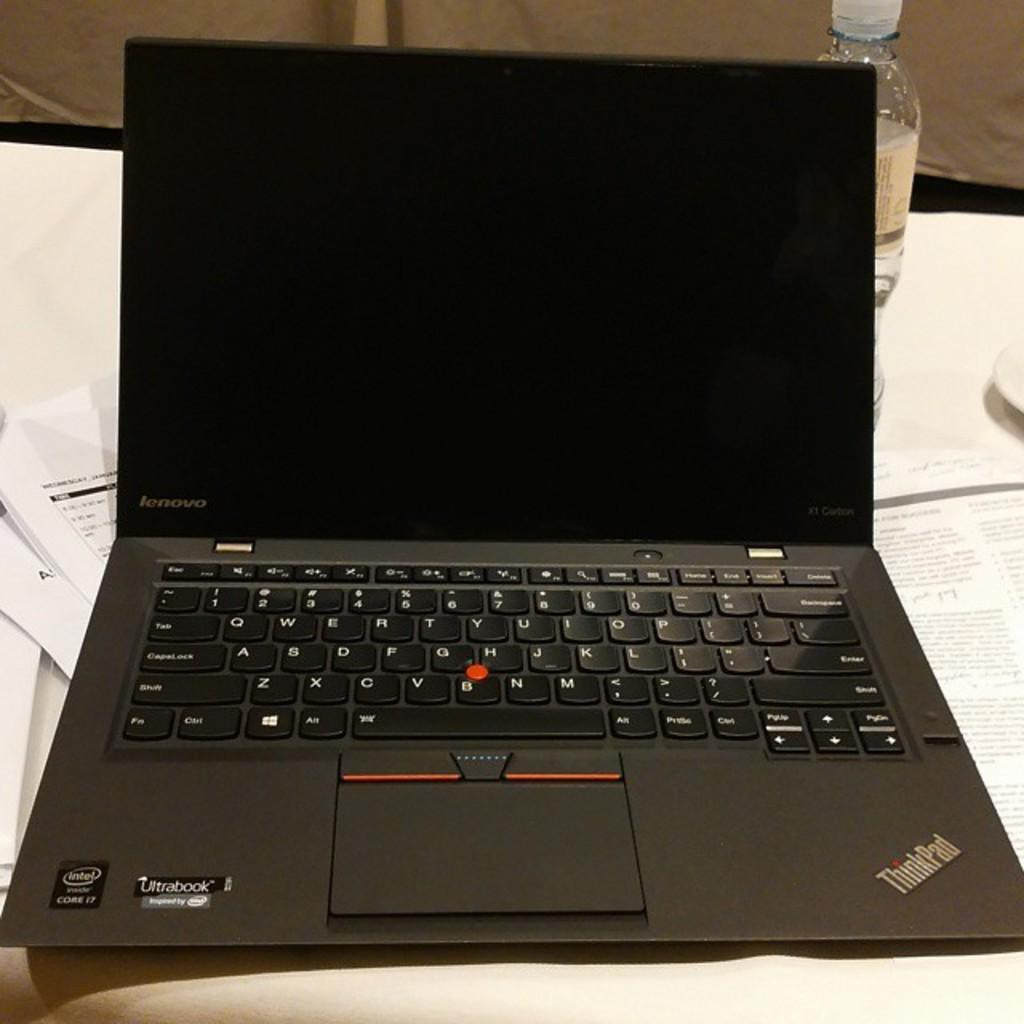<image>
Share a concise interpretation of the image provided. A Lenovo laptop is on a table in front of a bottle. 